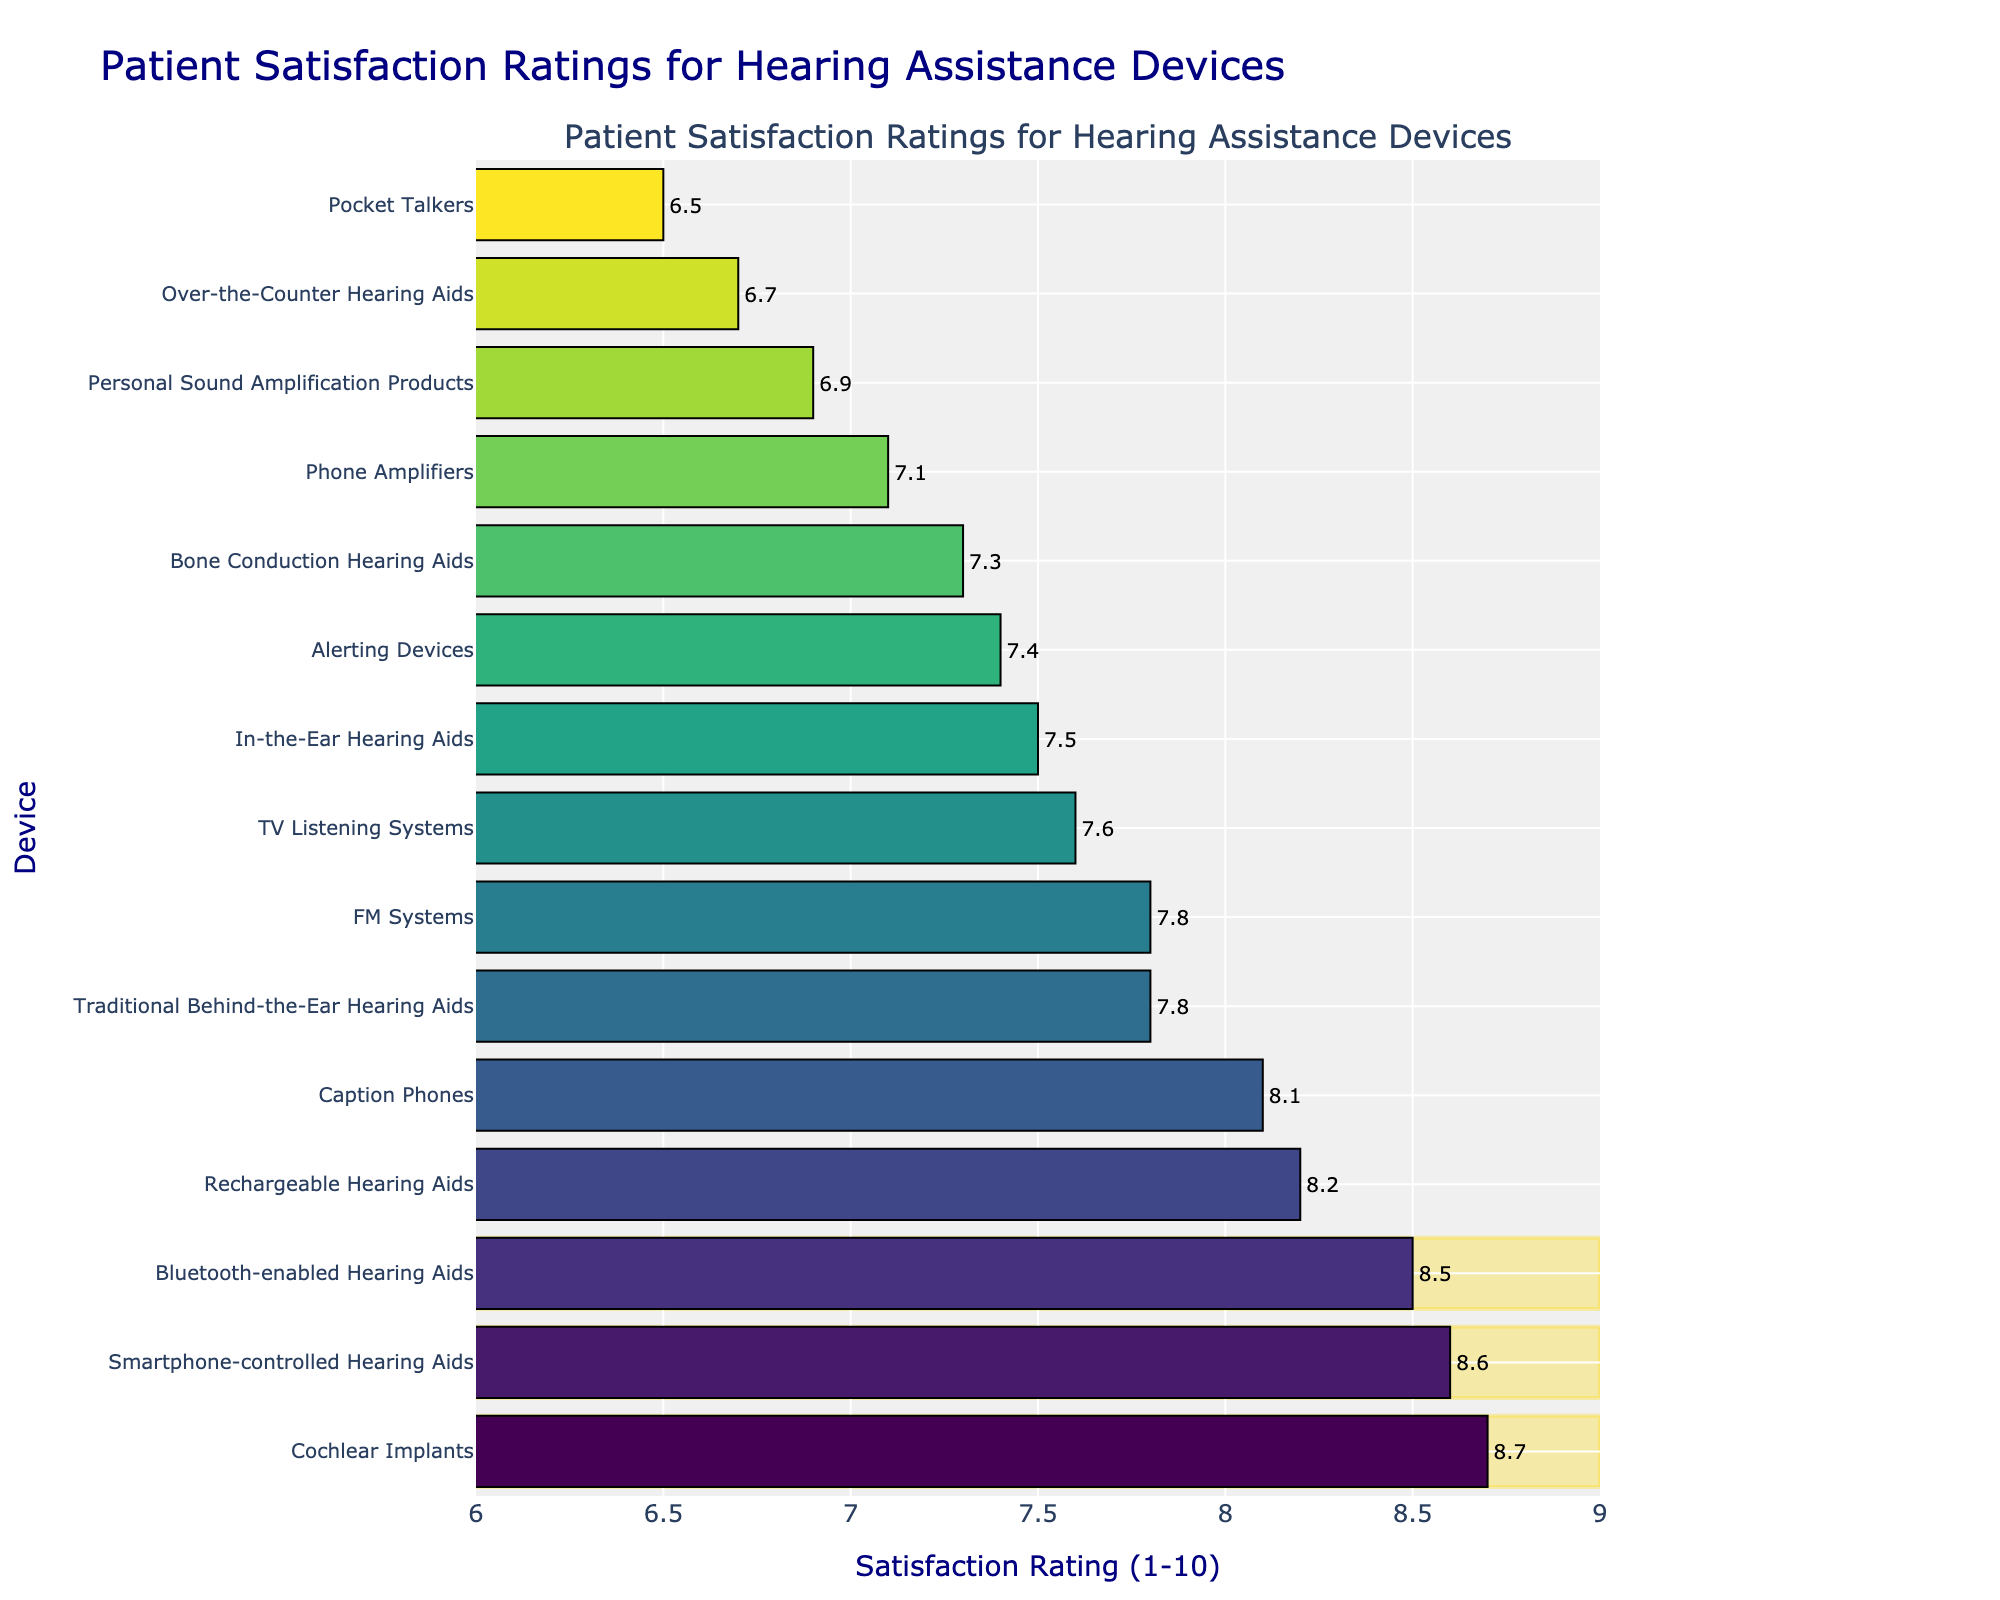Which device has the highest patient satisfaction rating? The device with the highest patient satisfaction rating is the one with the longest bar on the rightmost side of the plot.
Answer: Cochlear Implants How much higher is the patient satisfaction rating for Cochlear Implants compared to Pocket Talkers? Find the rating for Cochlear Implants (8.7) and the rating for Pocket Talkers (6.5). Subtract the lower rating from the higher rating: 8.7 - 6.5.
Answer: 2.2 Which device has the lowest patient satisfaction rating? The device with the shortest bar on the leftmost side of the plot indicates the lowest satisfaction rating.
Answer: Pocket Talkers What is the average satisfaction rating of Rechargeable Hearing Aids and Bluetooth-enabled Hearing Aids? Find the ratings for Rechargeable Hearing Aids (8.2) and Bluetooth-enabled Hearing Aids (8.5). Sum the two ratings and divide by 2: (8.2 + 8.5) / 2.
Answer: 8.35 Rank the top three devices by patient satisfaction rating. Identify the three longest bars, which represent the highest satisfaction ratings, and list the devices associated with those bars.
Answer: Cochlear Implants, Smartphone-controlled Hearing Aids, Bluetooth-enabled Hearing Aids What is the difference between the satisfaction ratings for Traditional Behind-the-Ear Hearing Aids and In-the-Ear Hearing Aids? Find the rating for Traditional Behind-the-Ear Hearing Aids (7.8) and the rating for In-the-Ear Hearing Aids (7.5). Subtract the lower rating from the higher rating: 7.8 - 7.5.
Answer: 0.3 How many devices have a satisfaction rating of 8.0 or higher? Count the number of bars that extend to or beyond the 8.0 mark on the x-axis.
Answer: 6 Which device has the closest satisfaction rating to the average of all devices? Calculate the average satisfaction rating for all devices. Then, find the device with a satisfaction rating closest to this average.
Answer: Caption Phones What is the range of satisfaction ratings across all devices? Find the highest rating (8.7) and the lowest rating (6.5). Subtract the lowest rating from the highest rating: 8.7 - 6.5.
Answer: 2.2 Which devices fall between the satisfaction ratings of 7.0 and 8.0? Identify all bars that have their lengths between the 7.0 and 8.0 marks on the x-axis.
Answer: Traditional Behind-the-Ear Hearing Aids, In-the-Ear Hearing Aids, Bone Conduction Hearing Aids, TV Listening Systems, Phone Amplifiers, FM Systems, Alerting Devices, Over-the-Counter Hearing Aids 